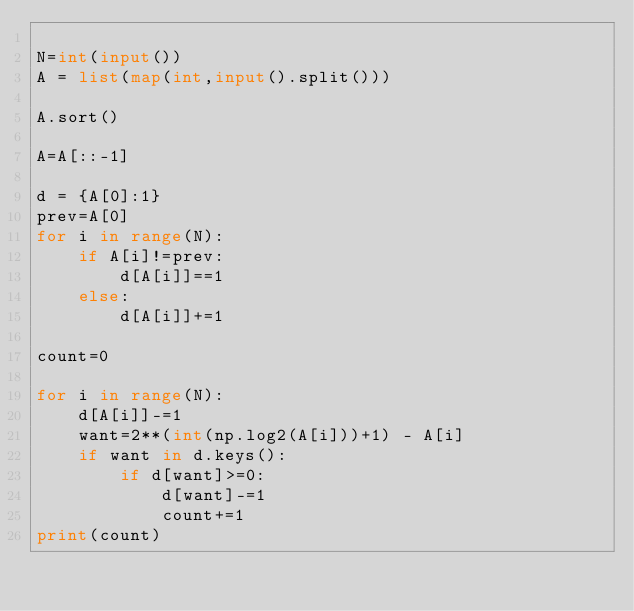<code> <loc_0><loc_0><loc_500><loc_500><_Python_>
N=int(input())
A = list(map(int,input().split()))
 
A.sort()
 
A=A[::-1]

d = {A[0]:1}
prev=A[0]
for i in range(N):
    if A[i]!=prev:
        d[A[i]]==1
    else:
        d[A[i]]+=1

count=0

for i in range(N):
    d[A[i]]-=1
    want=2**(int(np.log2(A[i]))+1) - A[i]
    if want in d.keys():
        if d[want]>=0:
            d[want]-=1
            count+=1
print(count)</code> 